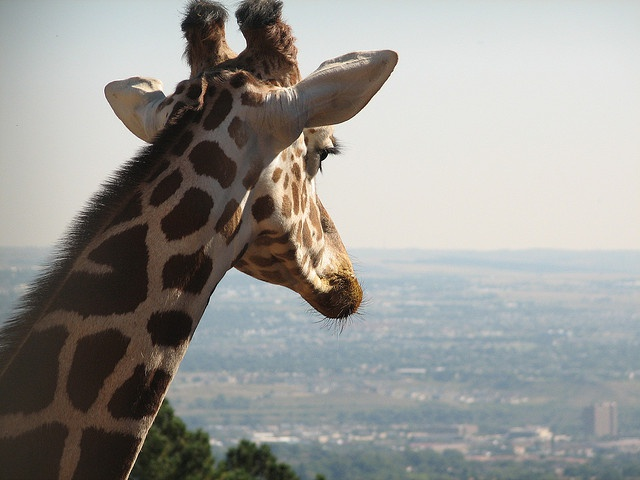Describe the objects in this image and their specific colors. I can see a giraffe in gray, black, and maroon tones in this image. 